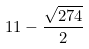Convert formula to latex. <formula><loc_0><loc_0><loc_500><loc_500>1 1 - \frac { \sqrt { 2 7 4 } } { 2 }</formula> 